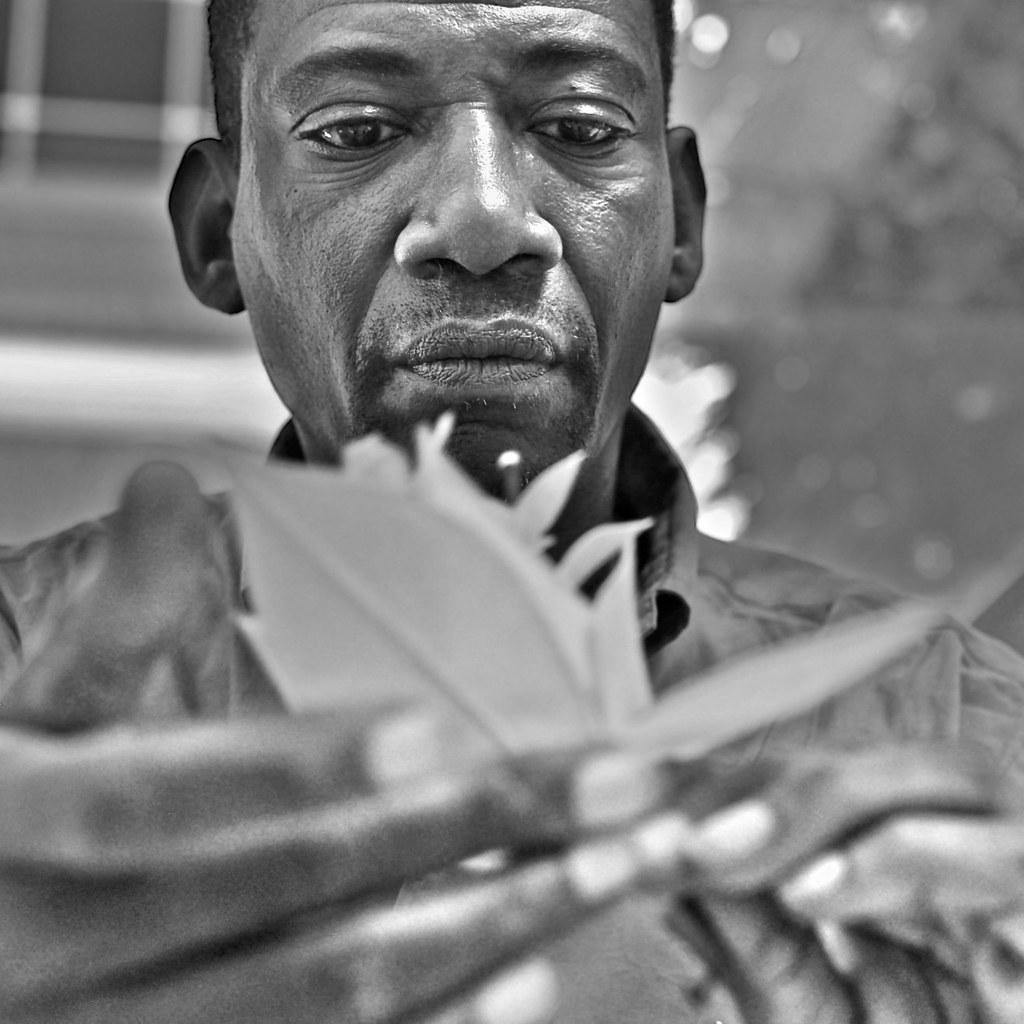What is the color scheme of the image? The image is black and white. What is the person in the image doing? The person is holding an object in the image. Can you describe the background of the image? The background of the image is blurred. How many bees can be seen buzzing around the person in the image? There are no bees present in the image. What type of gun is the person holding in the image? There is no gun present in the image; the person is holding an unspecified object. 